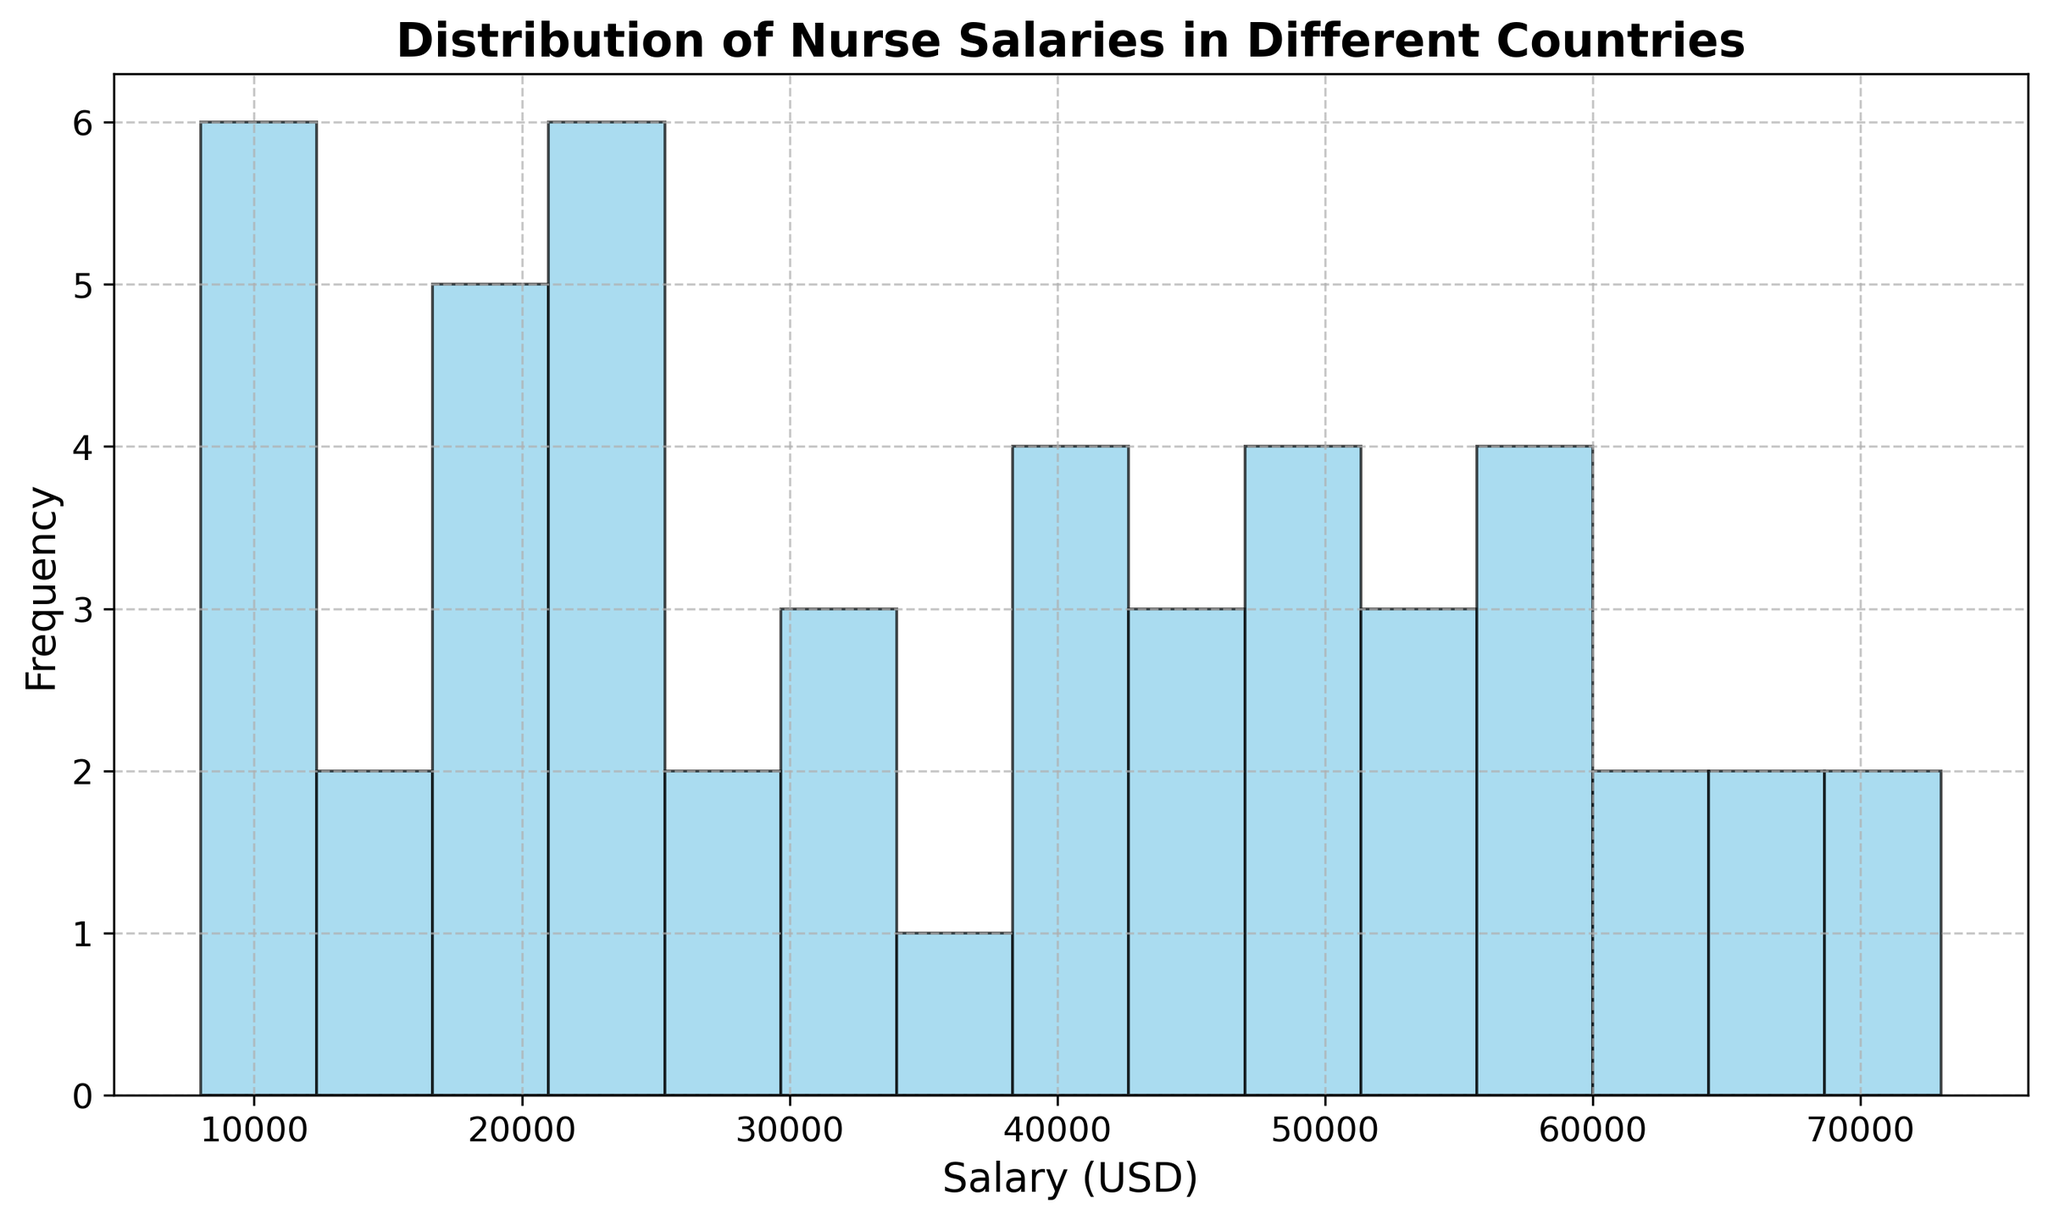What is the most frequent nurse salary range based on the histogram? The height of the bars in the histogram indicates the frequency of the nurse salaries. The bar that is the tallest shows the most frequent salary range.
Answer: The most frequent salary range is around $20,000-$30,000 How many countries have salaries less than $20,000? Count the number of bars in the histogram that are positioned to the left of the $20,000 mark.
Answer: There are 9 countries with salaries less than $20,000 Which salary range shows the highest frequency, $50,000-$60,000 or $60,000-$70,000? Compare the height of the bars in the salary ranges $50,000-$60,000 and $60,000-$70,000. The range with the higher bar has the higher frequency.
Answer: The $50,000-$60,000 range shows higher frequency Which salary range has the lowest frequency? Identify the bar with the smallest height on the histogram to determine the least frequent salary range.
Answer: The least frequent salary range is around $70,000-$80,000 What is the approximate median salary range of the distribution? The median salary is located at the midpoint of the salary distribution. Look for the bar that represents the middle value when salaries are ordered.
Answer: The median salary range is around $40,000-$50,000 Is the salary distribution left-skewed, right-skewed, or symmetric? Observe the general shape of the histogram. If most data is concentrated on the left with a tail extending to the right, it's right-skewed. If the reverse, it's left-skewed. If the data is evenly distributed, it is symmetric.
Answer: The salary distribution is right-skewed How many different salary ranges are there between $30,000 and $60,000? Count the number of bars within the $30,000 to $60,000 range on the histogram.
Answer: There are 4 different salary ranges between $30,000 and $60,000 What is the highest nurse salary represented in the histogram? The rightmost bar on the histogram represents the highest salary. Identify this bar and its value.
Answer: The highest nurse salary represented is $73,000 